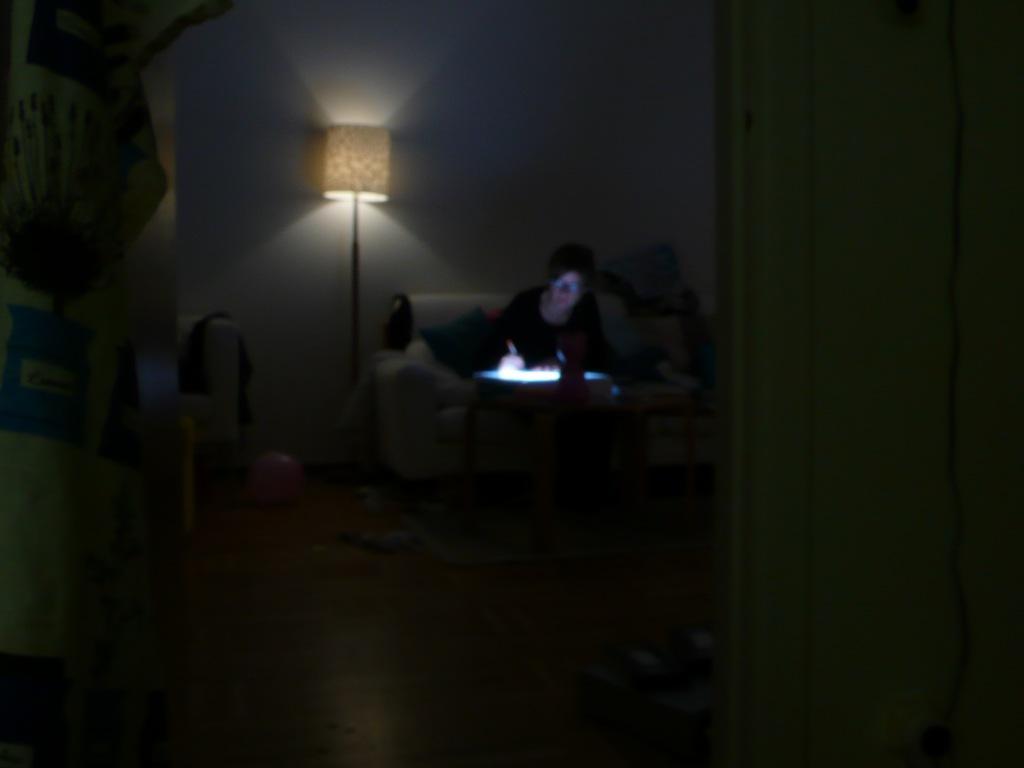Could you give a brief overview of what you see in this image? A person is sitting on a couch with pillows. In-front of this person there is a table with things. This is lamp. On the floor there is a carpet, ball and things.  